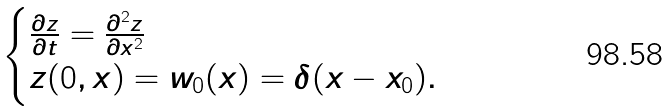Convert formula to latex. <formula><loc_0><loc_0><loc_500><loc_500>\begin{cases} \frac { \partial z } { \partial t } = \frac { \partial ^ { 2 } z } { \partial x ^ { 2 } } \\ z ( 0 , x ) = w _ { 0 } ( x ) = \delta ( x - x _ { 0 } ) . \end{cases}</formula> 